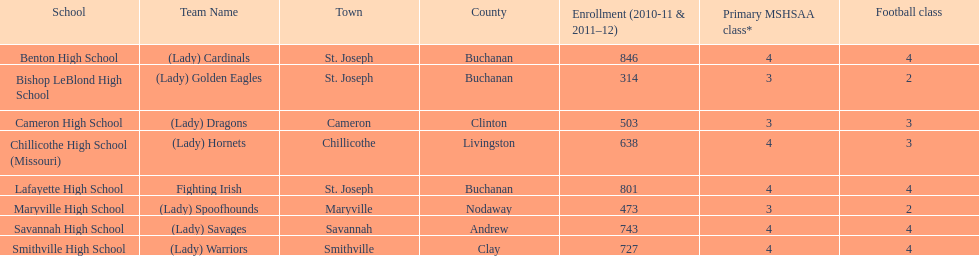What were the schools enrolled in 2010-2011 Benton High School, Bishop LeBlond High School, Cameron High School, Chillicothe High School (Missouri), Lafayette High School, Maryville High School, Savannah High School, Smithville High School. How many were enrolled in each? 846, 314, 503, 638, 801, 473, 743, 727. Which is the lowest number? 314. Which school had this number of students? Bishop LeBlond High School. 